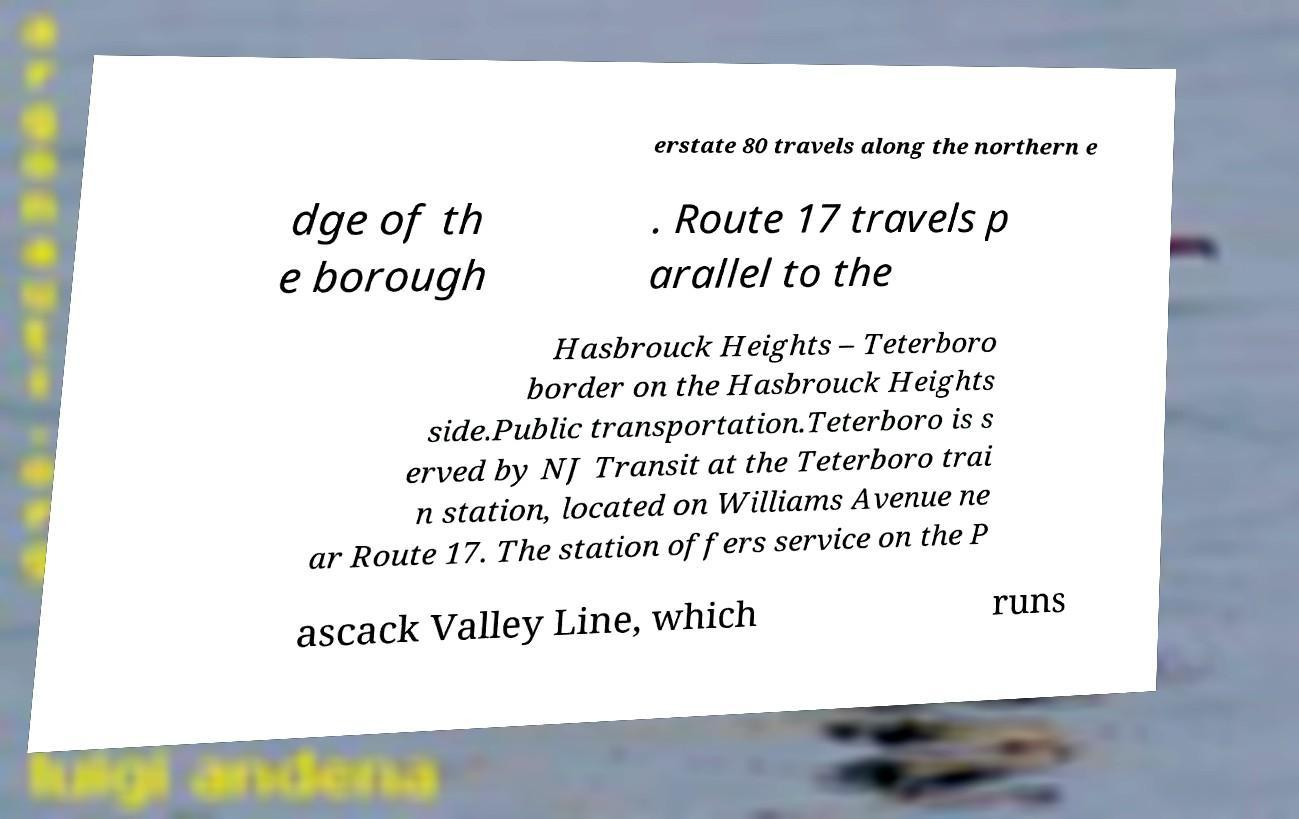Please read and relay the text visible in this image. What does it say? erstate 80 travels along the northern e dge of th e borough . Route 17 travels p arallel to the Hasbrouck Heights – Teterboro border on the Hasbrouck Heights side.Public transportation.Teterboro is s erved by NJ Transit at the Teterboro trai n station, located on Williams Avenue ne ar Route 17. The station offers service on the P ascack Valley Line, which runs 